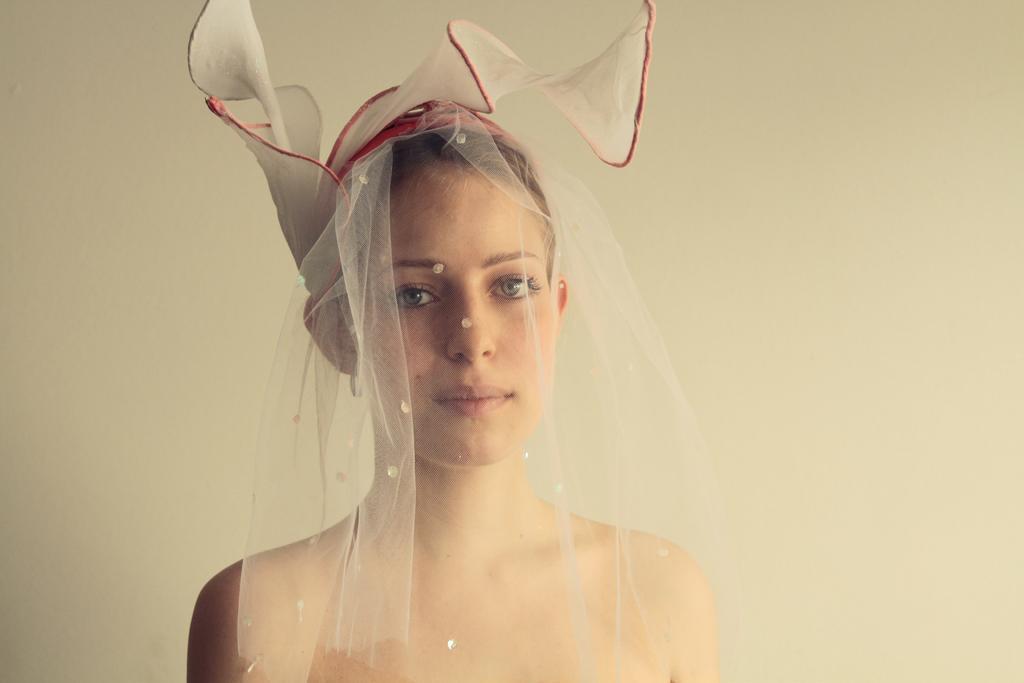In one or two sentences, can you explain what this image depicts? In the center of the image, we can see a lady wearing hair net and in the background, there is a wall. 